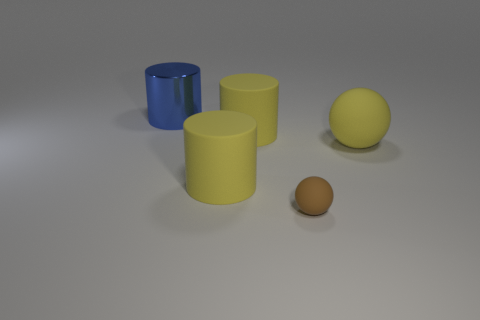Do the ball right of the brown rubber sphere and the large cylinder that is in front of the large yellow matte sphere have the same material?
Offer a very short reply. Yes. What material is the big object that is the same shape as the small brown thing?
Make the answer very short. Rubber. Is the blue object made of the same material as the small brown sphere?
Offer a very short reply. No. There is a rubber ball right of the brown ball that is to the left of the large matte ball; what color is it?
Provide a short and direct response. Yellow. The other yellow sphere that is made of the same material as the tiny ball is what size?
Your response must be concise. Large. How many other big blue metal objects are the same shape as the blue thing?
Provide a short and direct response. 0. What number of things are objects that are in front of the big metal cylinder or objects that are in front of the blue metal cylinder?
Offer a very short reply. 4. There is a big blue shiny thing left of the big ball; what number of large things are right of it?
Your answer should be very brief. 3. Does the thing that is right of the tiny matte ball have the same shape as the large blue object behind the brown thing?
Make the answer very short. No. Is there a large thing made of the same material as the brown ball?
Your answer should be compact. Yes. 